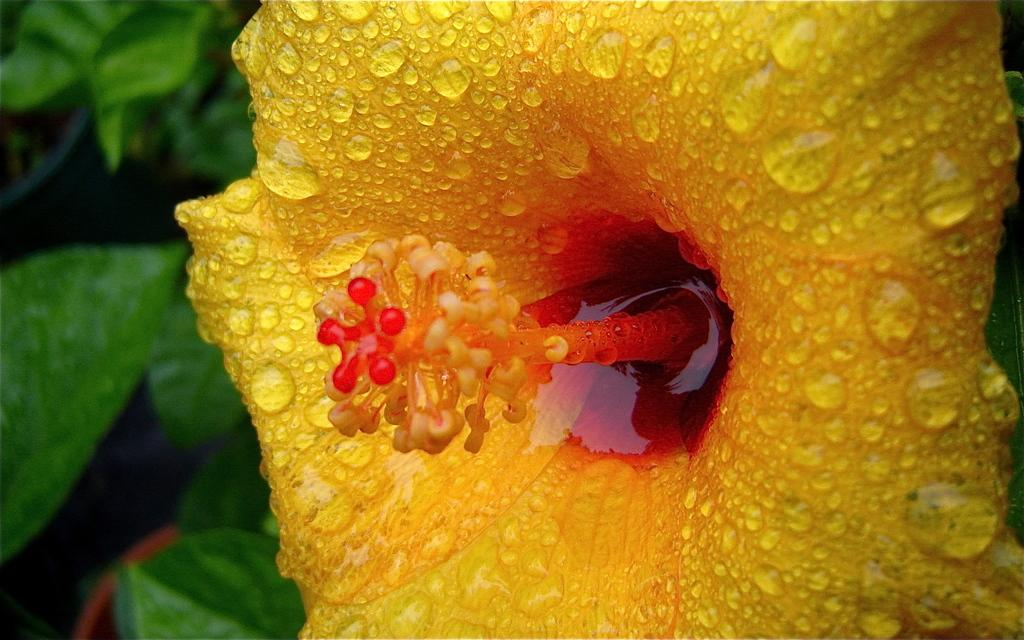What is the main subject of the image? There is a flower in the image. Can you describe the colors of the flower? The flower has yellow and red colors. What else can be seen on the flower? There are water drops on the flower. What type of vegetation is visible in the background of the image? There are green leaves in the background of the image. What type of division is taking place in the image? There is no division taking place in the image; it features a flower with water drops and green leaves in the background. Can you tell me how many boats are present in the harbor in the image? There is no harbor or boats present in the image; it features a flower with water drops and green leaves in the background. 